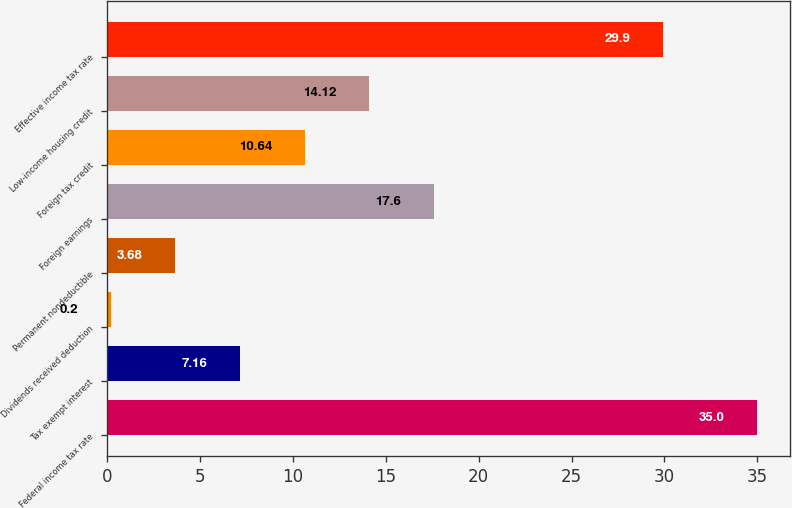Convert chart to OTSL. <chart><loc_0><loc_0><loc_500><loc_500><bar_chart><fcel>Federal income tax rate<fcel>Tax exempt interest<fcel>Dividends received deduction<fcel>Permanent nondeductible<fcel>Foreign earnings<fcel>Foreign tax credit<fcel>Low-income housing credit<fcel>Effective income tax rate<nl><fcel>35<fcel>7.16<fcel>0.2<fcel>3.68<fcel>17.6<fcel>10.64<fcel>14.12<fcel>29.9<nl></chart> 